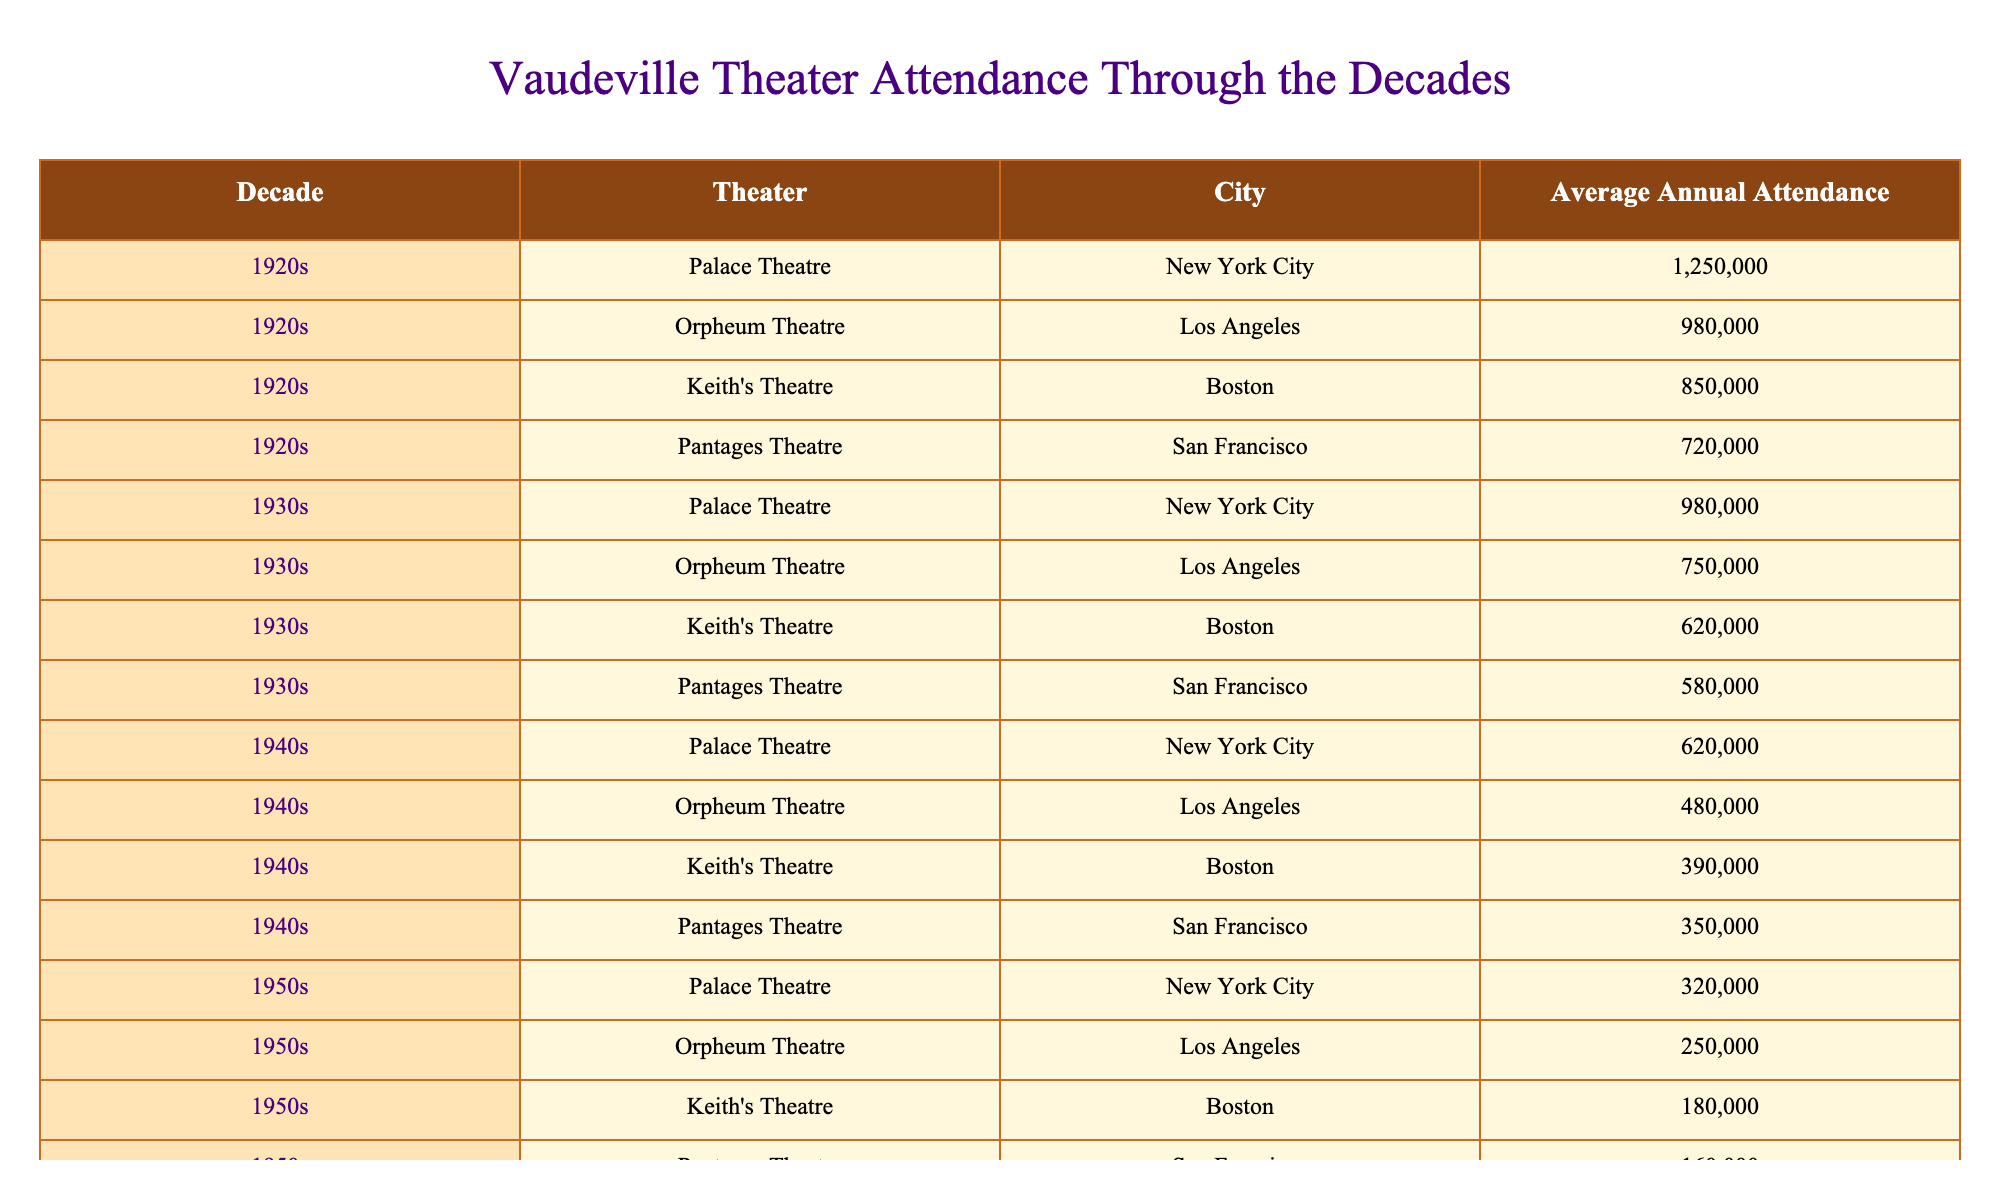What was the average annual attendance at the Palace Theatre in the 1920s? The table shows that the average annual attendance at the Palace Theatre in the 1920s was 1,250,000.
Answer: 1,250,000 Which decade had the highest average annual attendance at the Orpheum Theatre in Los Angeles? The highest average annual attendance at the Orpheum Theatre in Los Angeles was in the 1920s, with 980,000 attendees.
Answer: 1920s What was the average attendance of the Keith's Theatre in Boston during the 1930s? According to the table, the average attendance at Keith's Theatre in Boston during the 1930s was 620,000.
Answer: 620,000 Did the attendance at the Pantages Theatre in San Francisco decline from the 1920s to the 1940s? Yes, the average annual attendance at the Pantages Theatre declined from 720,000 in the 1920s to 350,000 in the 1940s.
Answer: Yes What is the total average annual attendance across all theaters in the 1950s? To find the total, we add the average attendance of each theater in the 1950s: 320,000 + 250,000 + 180,000 + 160,000 = 910,000.
Answer: 910,000 In which decade did the Palace Theatre in New York City see the least attendance? The lowest average annual attendance for the Palace Theatre in New York City occurred in the 1940s, with 620,000 attendees.
Answer: 1940s Was the average annual attendance at the Orpheum Theatre in Los Angeles ever above 900,000? No, the highest attendance recorded was 980,000 in the 1920s, but it did not exceed that number in any other decade.
Answer: No What was the change in attendance at the Keith's Theatre in Boston from the 1920s to the 1960s? In the 1920s, the attendance was 850,000, and in the 1960s, it was 80,000, resulting in a decrease of 770,000.
Answer: Decrease of 770,000 Which theater had the highest attendance in the 1940s? The Palace Theatre in New York City had the highest attendance in the 1940s, with 620,000 attendees.
Answer: Palace Theatre How did the average annual attendance at the Pantages Theatre in San Francisco change from the 1930s to the 1950s? The attendance decreased from 580,000 in the 1930s to 160,000 in the 1950s, indicating a decline of 420,000.
Answer: Decline of 420,000 